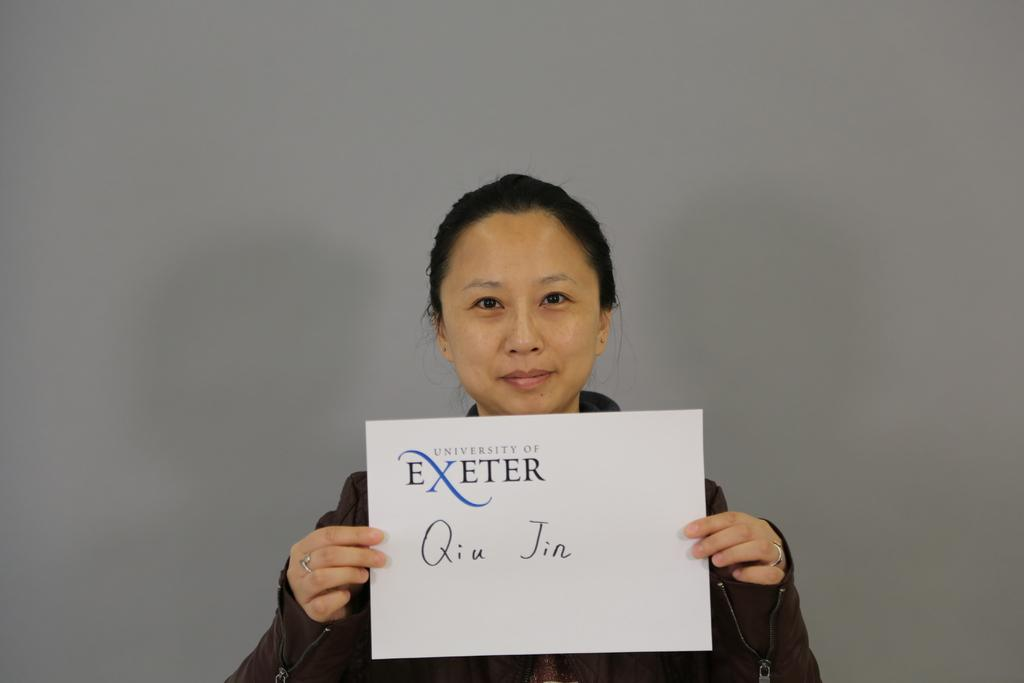Who is the main subject in the image? There is a woman in the image. What is the woman holding in the image? The woman is holding a card. What can be seen written on the card? The card has a name written on it. Who is the woman looking at in the image? The woman is looking at someone. What type of discovery is the woman making in the image? There is no indication of a discovery in the image; the woman is simply holding a card with a name written on it and looking at someone. 